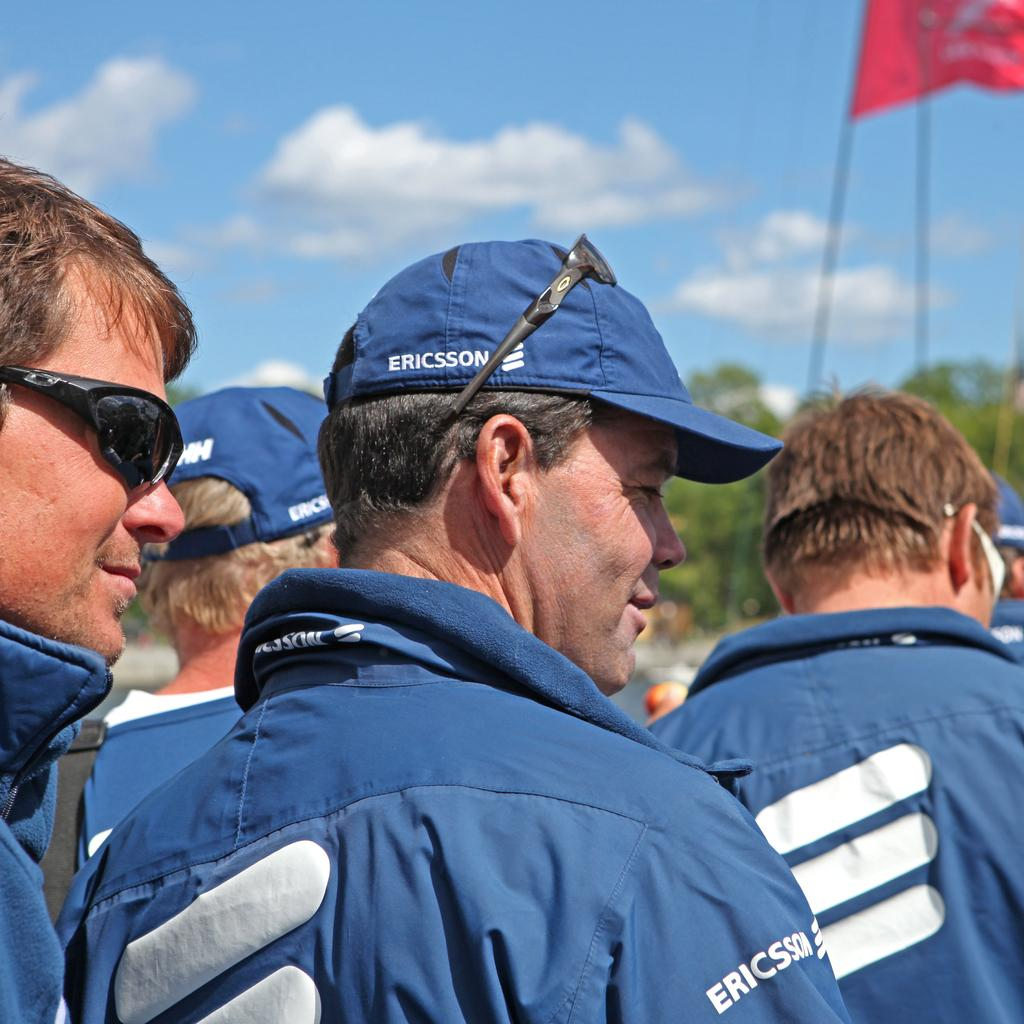Who or what can be seen in the image? There are people in the image. Where is the flag located in the image? The flag is on the right side of the image. What can be seen in the background of the image? There are trees and the sky visible in the background of the image. How many icicles are hanging from the trees in the image? There are no icicles present in the image, as the trees and sky suggest a warm or temperate climate. 